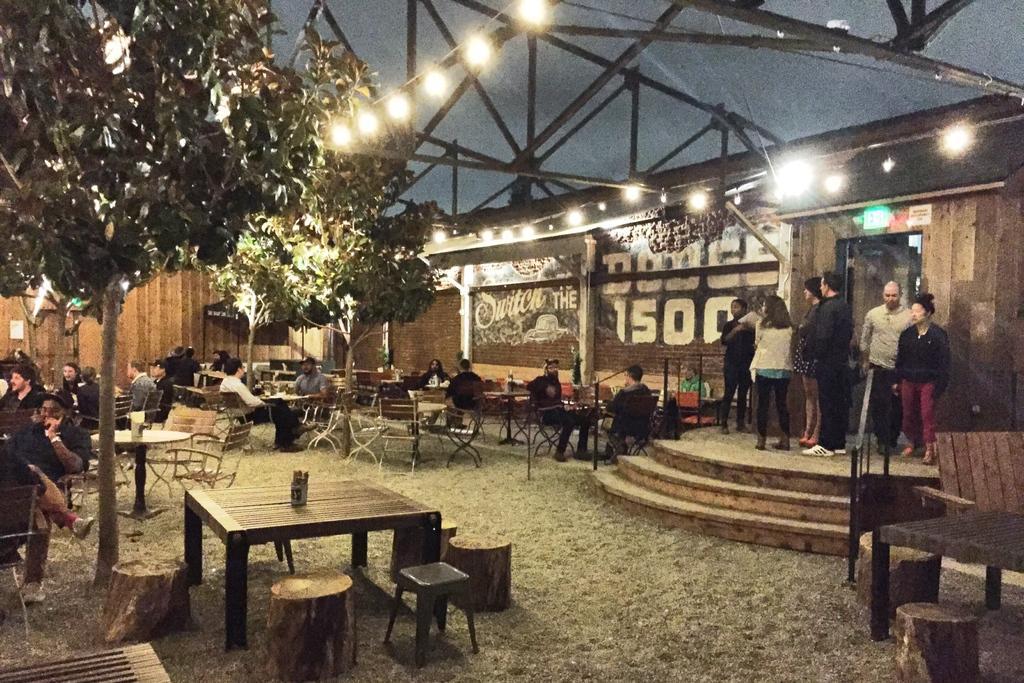In one or two sentences, can you explain what this image depicts? In this image, on the ground there is grass and in the left side of the image there is a table in black color and there some people sitting on the chairs, In the right side of the image there are some people standing on the floor. 